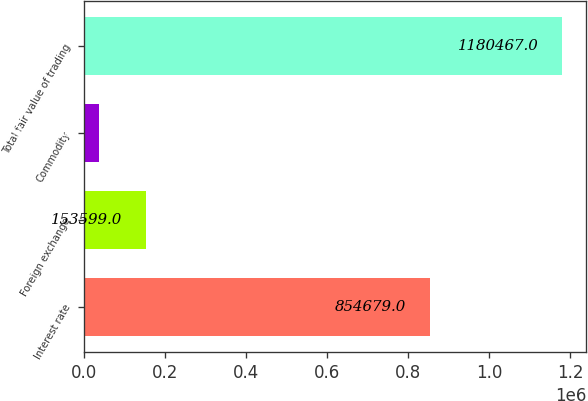Convert chart to OTSL. <chart><loc_0><loc_0><loc_500><loc_500><bar_chart><fcel>Interest rate<fcel>Foreign exchange<fcel>Commodity<fcel>Total fair value of trading<nl><fcel>854679<fcel>153599<fcel>35738<fcel>1.18047e+06<nl></chart> 